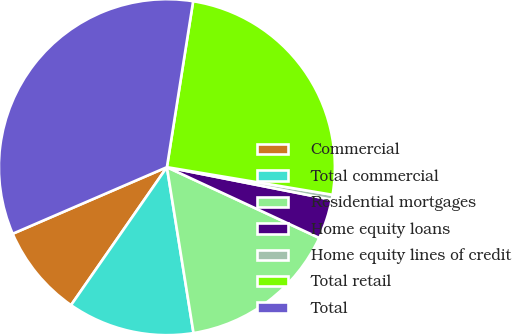Convert chart. <chart><loc_0><loc_0><loc_500><loc_500><pie_chart><fcel>Commercial<fcel>Total commercial<fcel>Residential mortgages<fcel>Home equity loans<fcel>Home equity lines of credit<fcel>Total retail<fcel>Total<nl><fcel>8.85%<fcel>12.2%<fcel>15.55%<fcel>3.82%<fcel>0.47%<fcel>25.14%<fcel>33.99%<nl></chart> 